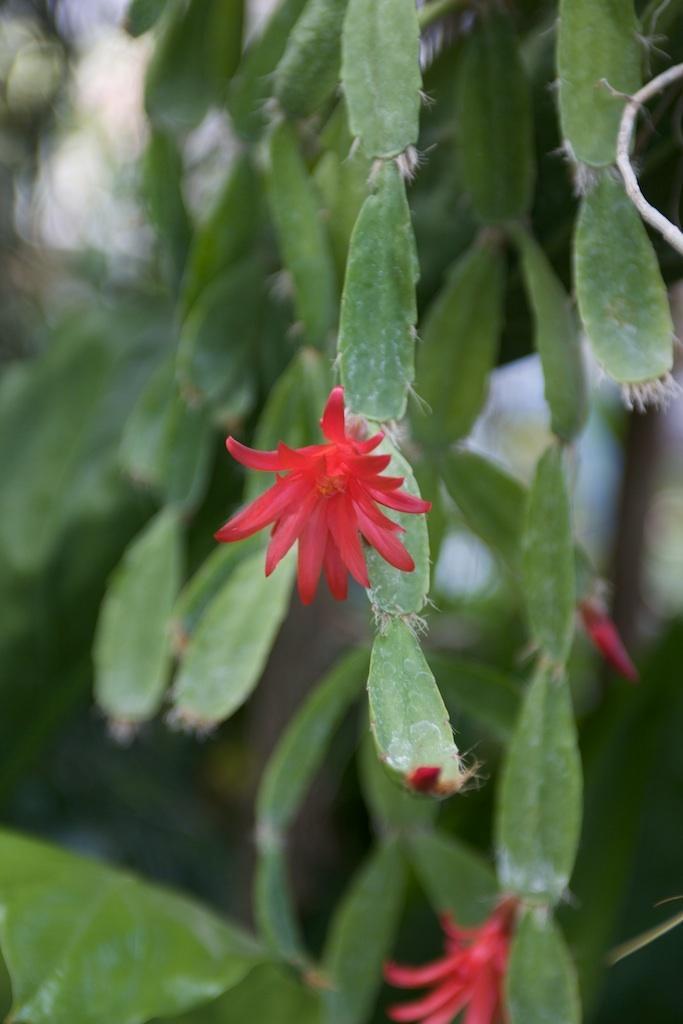Can you describe this image briefly? In the image we can see orchid cactus and a flower red in color. 